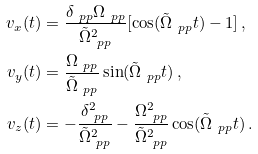<formula> <loc_0><loc_0><loc_500><loc_500>v _ { x } ( t ) & = \frac { \delta _ { \ p p } \Omega _ { \ p p } } { \tilde { \Omega } _ { \ p p } ^ { 2 } } [ \cos ( \tilde { \Omega } _ { \ p p } t ) - 1 ] \, , \\ v _ { y } ( t ) & = \frac { \Omega _ { \ p p } } { \tilde { \Omega } _ { \ p p } } \sin ( \tilde { \Omega } _ { \ p p } t ) \, , \\ v _ { z } ( t ) & = - \frac { \delta _ { \ p p } ^ { 2 } } { \tilde { \Omega } _ { \ p p } ^ { 2 } } - \frac { \Omega _ { \ p p } ^ { 2 } } { \tilde { \Omega } _ { \ p p } ^ { 2 } } \cos ( \tilde { \Omega } _ { \ p p } t ) \, .</formula> 